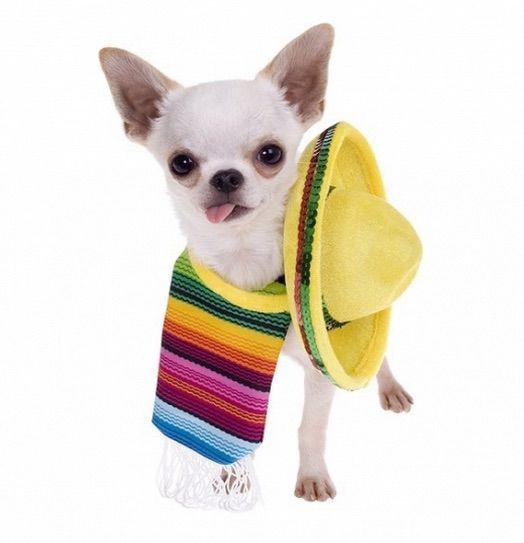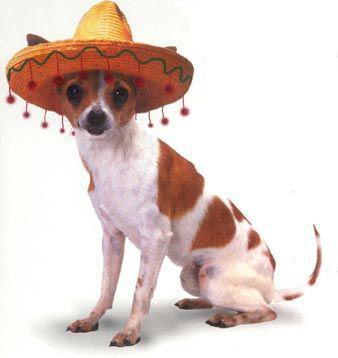The first image is the image on the left, the second image is the image on the right. Considering the images on both sides, is "Each image shows a chihuahua dog wearing a sombrero on top of its head." valid? Answer yes or no. No. The first image is the image on the left, the second image is the image on the right. Evaluate the accuracy of this statement regarding the images: "There are two chihuahuas wearing sombreros on top of their heads.". Is it true? Answer yes or no. No. 